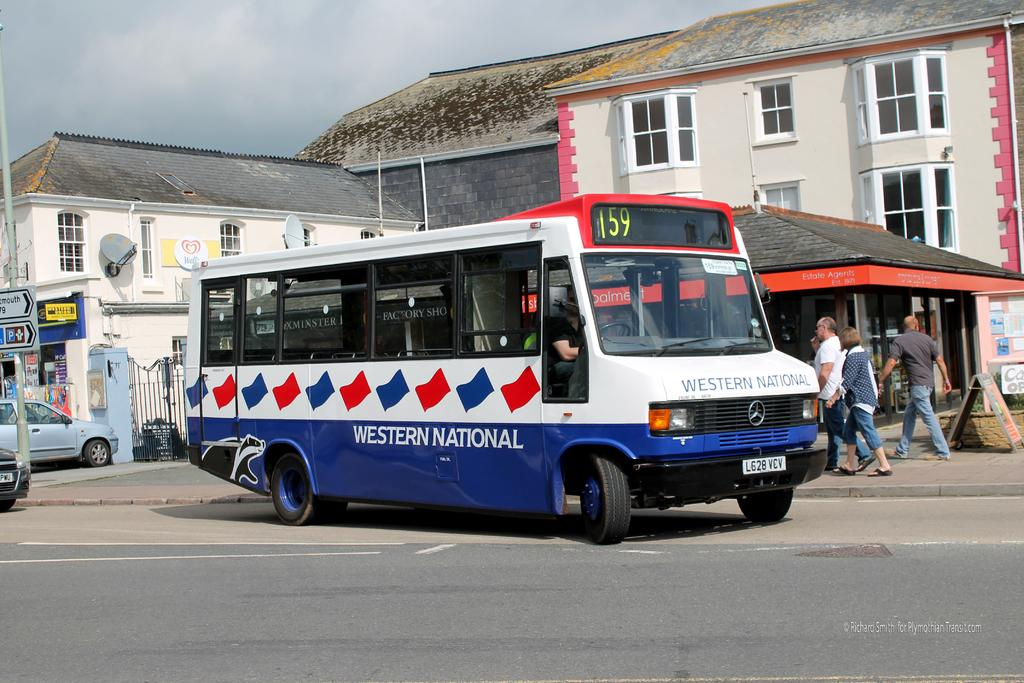<image>
Share a concise interpretation of the image provided. A western National bus is driving through a small town, past people who are walking down the street. 